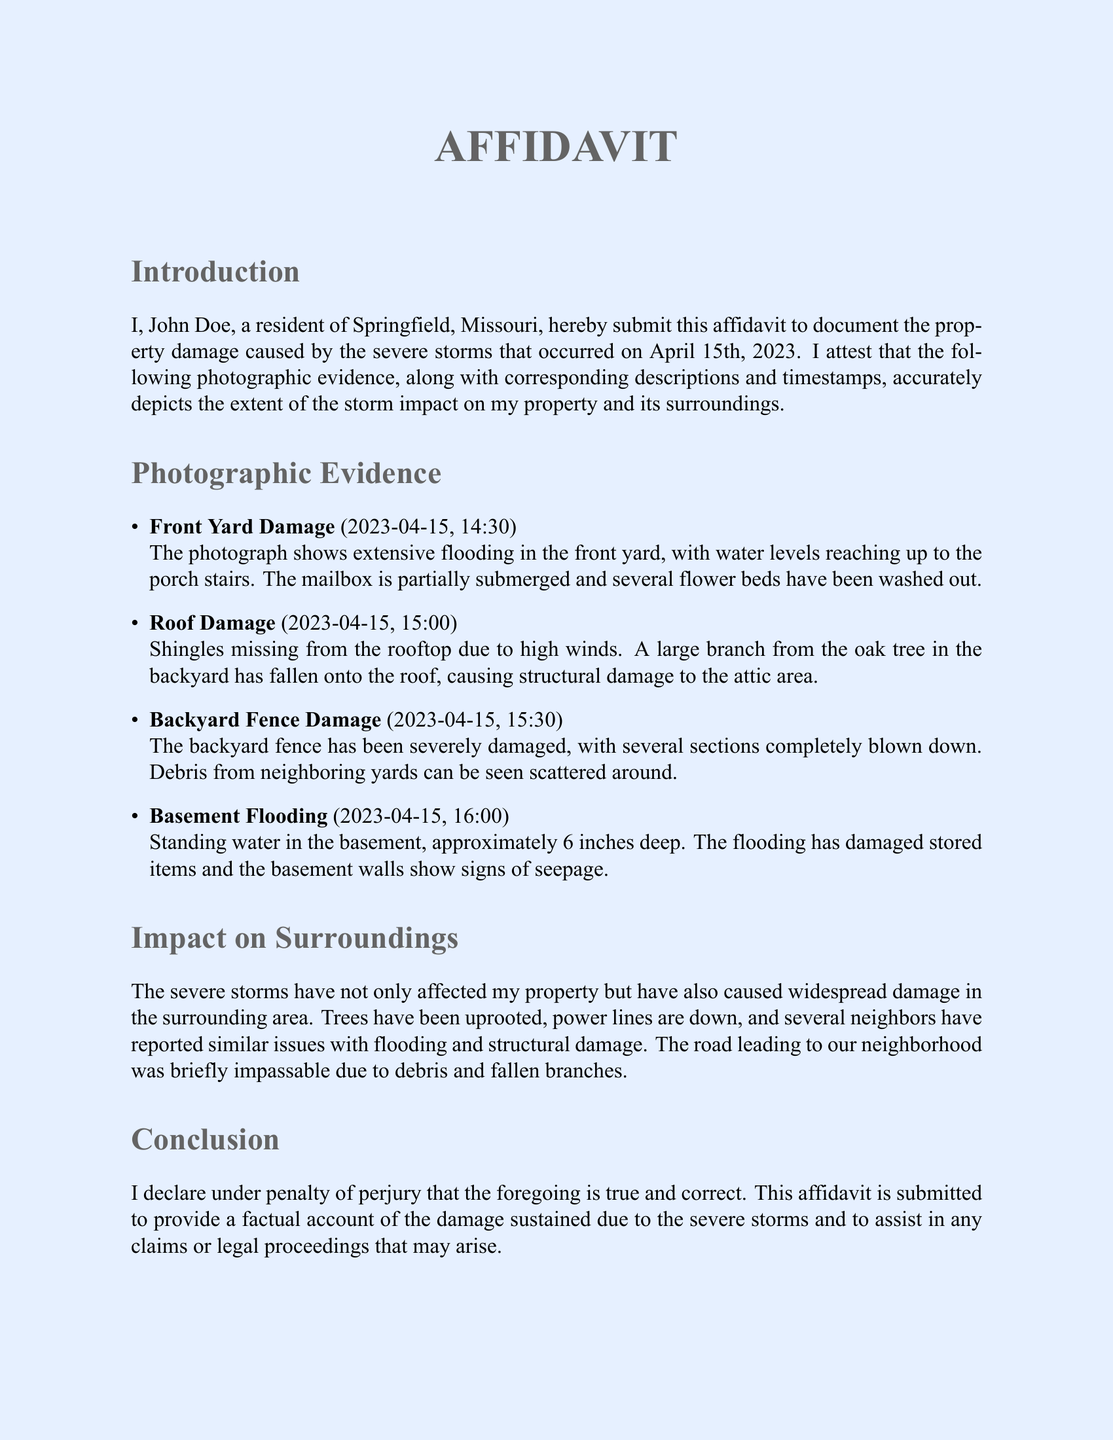What is the date of the storm? The document states the storm occurred on April 15th, 2023.
Answer: April 15th, 2023 Who is the affiant? The affidavit indicates that the affiant is John Doe, a resident of Springfield, Missouri.
Answer: John Doe What time was the roof damage photographed? The document specifies that the roof damage was photographed at 15:00.
Answer: 15:00 What extent of flooding was reported in the basement? The affidavit mentions that there was approximately 6 inches of standing water in the basement.
Answer: 6 inches What type of damage was reported to the yard? The document describes extensive flooding as the type of damage in the front yard.
Answer: Flooding How many sections of the backyard fence were damaged? The affidavit states that several sections of the backyard fence were completely blown down.
Answer: Several sections What condition was the road leading to the neighborhood? The document notes that the road was briefly impassable due to debris and fallen branches.
Answer: Impassable What is the purpose of this affidavit? The affidavit serves to document the storm damage and assist in claims or legal proceedings.
Answer: Document storm damage What is the date on the signature line? The document shows that the affidavit was signed on April 20th, 2023.
Answer: April 20th, 2023 